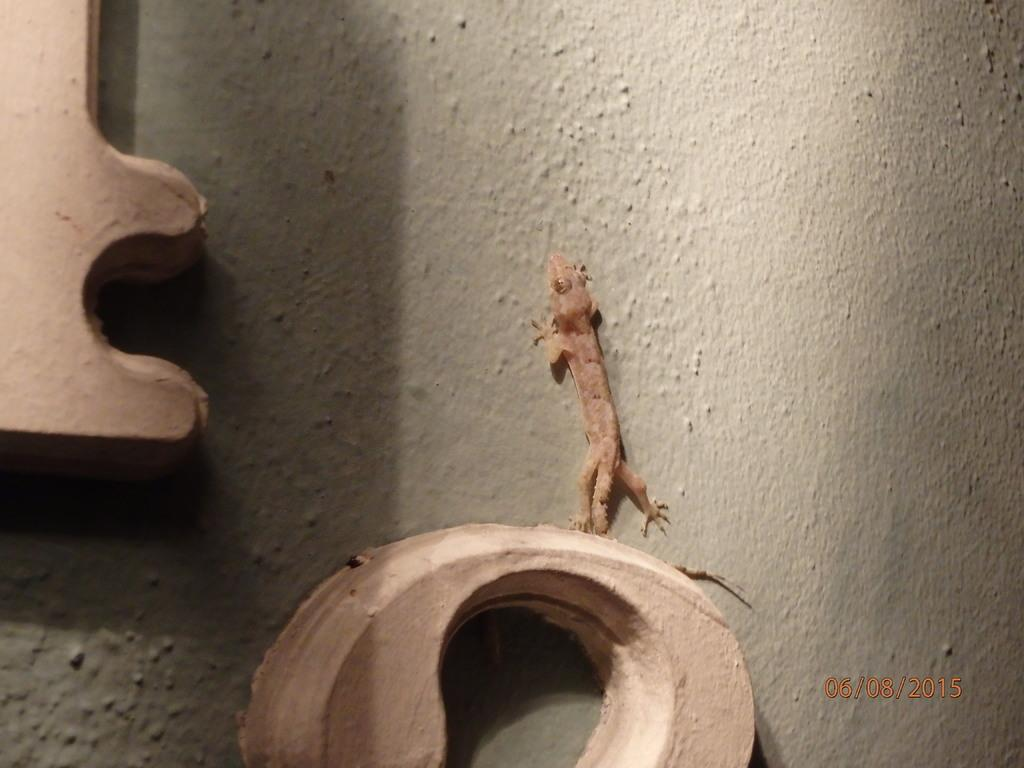How many objects can be seen in the image? There are two objects in the image. What is one of the objects in the image? There is a lizard on the wall in the image. What type of curve can be seen in the image? There is no curve present in the image. How many spoons are visible in the image? There is no spoon present in the image. 